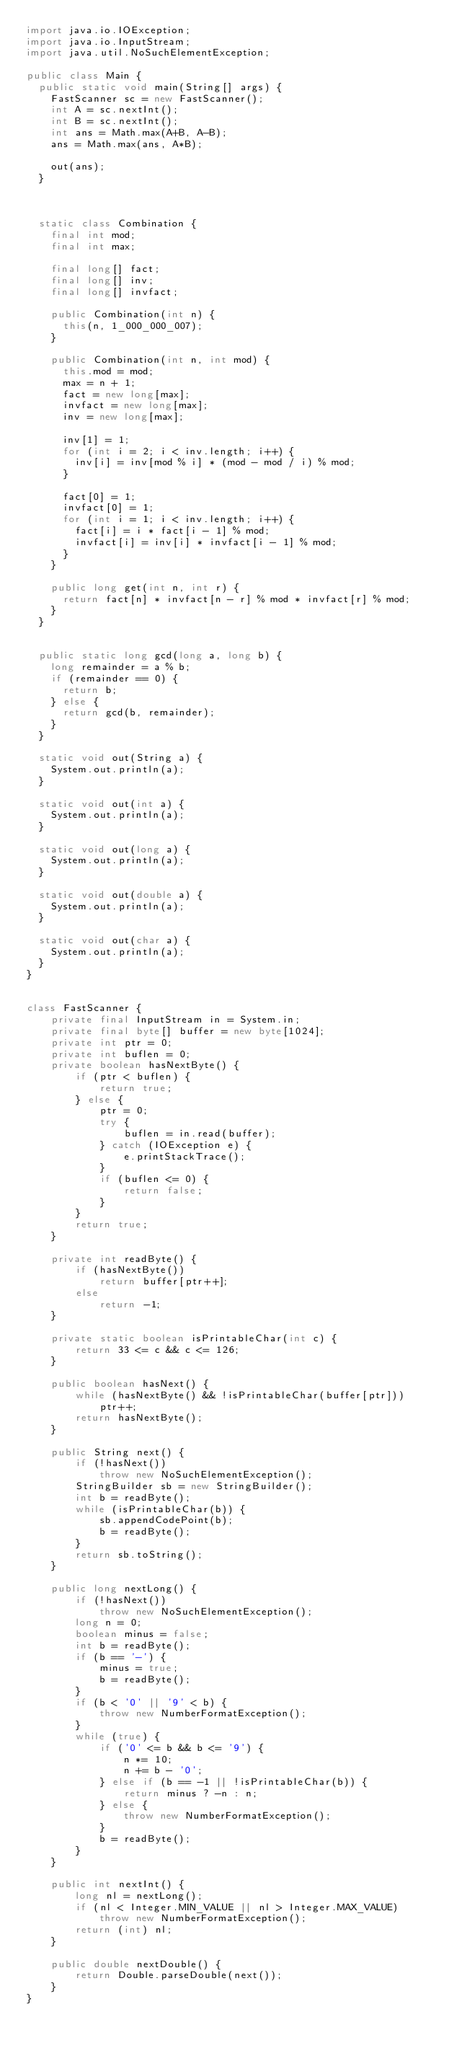Convert code to text. <code><loc_0><loc_0><loc_500><loc_500><_Java_>import java.io.IOException;
import java.io.InputStream;
import java.util.NoSuchElementException;

public class Main {
	public static void main(String[] args) {
		FastScanner sc = new FastScanner();
		int A = sc.nextInt();
		int B = sc.nextInt();
		int ans = Math.max(A+B, A-B);
		ans = Math.max(ans, A*B);

		out(ans);
	}



	static class Combination {
		final int mod;
		final int max;

		final long[] fact;
		final long[] inv;
		final long[] invfact;

		public Combination(int n) {
			this(n, 1_000_000_007);
		}

		public Combination(int n, int mod) {
			this.mod = mod;
			max = n + 1;
			fact = new long[max];
			invfact = new long[max];
			inv = new long[max];

			inv[1] = 1;
			for (int i = 2; i < inv.length; i++) {
				inv[i] = inv[mod % i] * (mod - mod / i) % mod;
			}

			fact[0] = 1;
			invfact[0] = 1;
			for (int i = 1; i < inv.length; i++) {
				fact[i] = i * fact[i - 1] % mod;
				invfact[i] = inv[i] * invfact[i - 1] % mod;
			}
		}

		public long get(int n, int r) {
			return fact[n] * invfact[n - r] % mod * invfact[r] % mod;
		}
	}


	public static long gcd(long a, long b) {
		long remainder = a % b;
		if (remainder == 0) {
			return b;
		} else {
			return gcd(b, remainder);
		}
	}

	static void out(String a) {
		System.out.println(a);
	}

	static void out(int a) {
		System.out.println(a);
	}

	static void out(long a) {
		System.out.println(a);
	}

	static void out(double a) {
		System.out.println(a);
	}

	static void out(char a) {
		System.out.println(a);
	}
}


class FastScanner {
    private final InputStream in = System.in;
    private final byte[] buffer = new byte[1024];
    private int ptr = 0;
    private int buflen = 0;
    private boolean hasNextByte() {
        if (ptr < buflen) {
            return true;
        } else {
            ptr = 0;
            try {
                buflen = in.read(buffer);
            } catch (IOException e) {
                e.printStackTrace();
            }
            if (buflen <= 0) {
                return false;
            }
        }
        return true;
    }

    private int readByte() {
        if (hasNextByte())
            return buffer[ptr++];
        else
            return -1;
    }

    private static boolean isPrintableChar(int c) {
        return 33 <= c && c <= 126;
    }

    public boolean hasNext() {
        while (hasNextByte() && !isPrintableChar(buffer[ptr]))
            ptr++;
        return hasNextByte();
    }

    public String next() {
        if (!hasNext())
            throw new NoSuchElementException();
        StringBuilder sb = new StringBuilder();
        int b = readByte();
        while (isPrintableChar(b)) {
            sb.appendCodePoint(b);
            b = readByte();
        }
        return sb.toString();
    }

    public long nextLong() {
        if (!hasNext())
            throw new NoSuchElementException();
        long n = 0;
        boolean minus = false;
        int b = readByte();
        if (b == '-') {
            minus = true;
            b = readByte();
        }
        if (b < '0' || '9' < b) {
            throw new NumberFormatException();
        }
        while (true) {
            if ('0' <= b && b <= '9') {
                n *= 10;
                n += b - '0';
            } else if (b == -1 || !isPrintableChar(b)) {
                return minus ? -n : n;
            } else {
                throw new NumberFormatException();
            }
            b = readByte();
        }
    }

    public int nextInt() {
        long nl = nextLong();
        if (nl < Integer.MIN_VALUE || nl > Integer.MAX_VALUE)
            throw new NumberFormatException();
        return (int) nl;
    }

    public double nextDouble() {
        return Double.parseDouble(next());
    }
}
</code> 